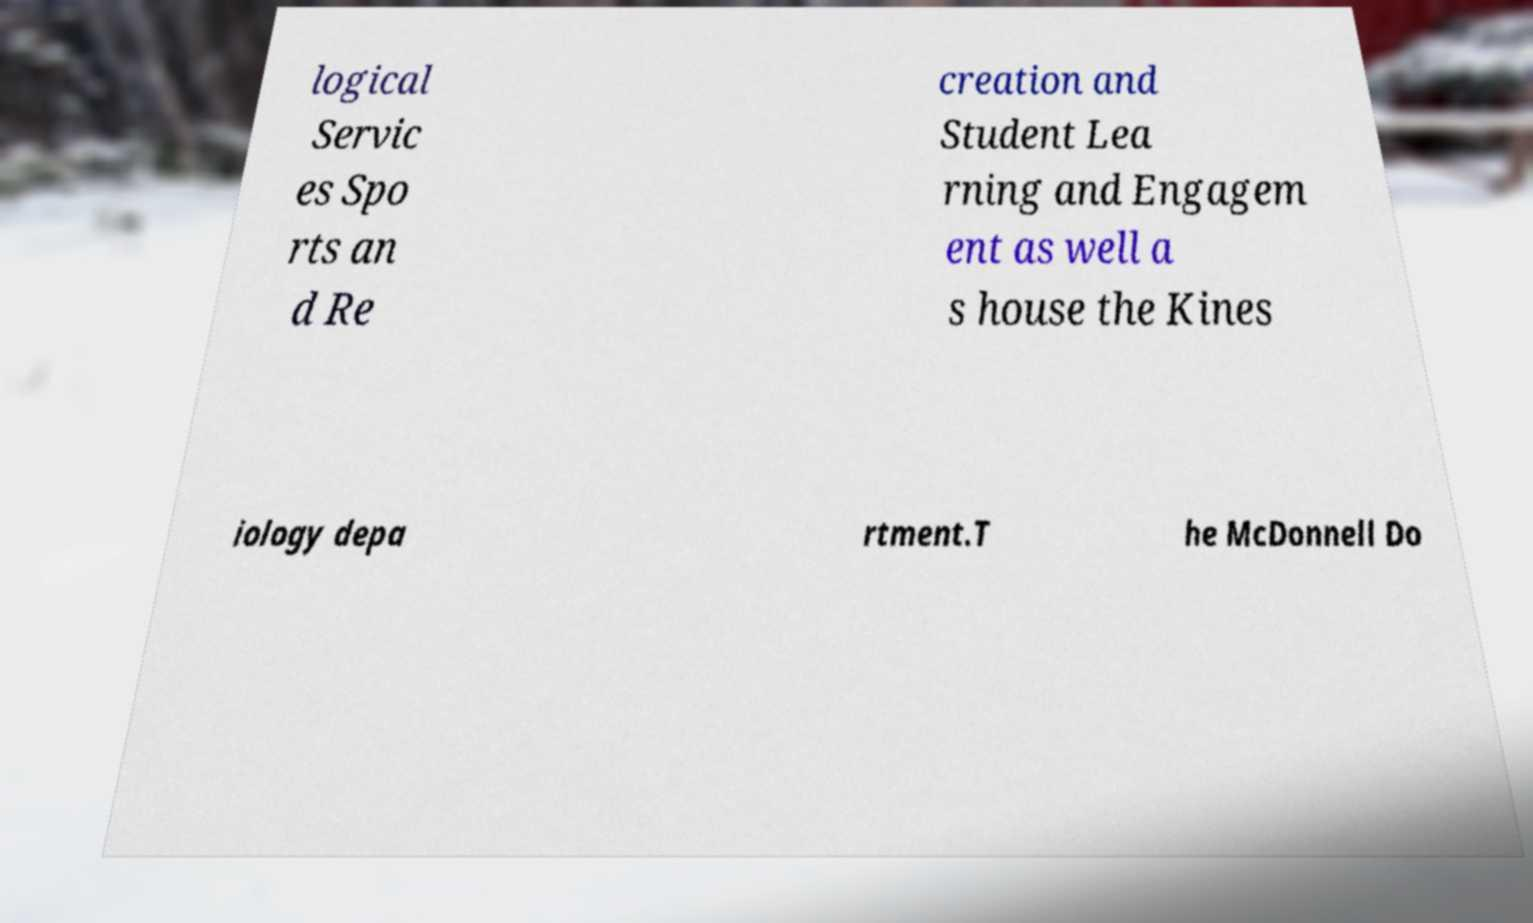Please identify and transcribe the text found in this image. logical Servic es Spo rts an d Re creation and Student Lea rning and Engagem ent as well a s house the Kines iology depa rtment.T he McDonnell Do 